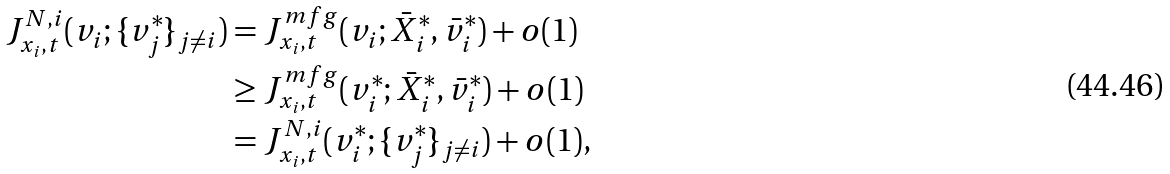<formula> <loc_0><loc_0><loc_500><loc_500>J _ { x _ { i } , t } ^ { N , i } ( v _ { i } ; \{ v ^ { * } _ { j } \} _ { j \neq i } ) & = J _ { x _ { i } , t } ^ { m f g } ( v _ { i } ; \bar { X } _ { i } ^ { * } , \bar { v } ^ { * } _ { i } ) + o ( 1 ) \\ & \geq J _ { x _ { i } , t } ^ { m f g } ( v ^ { * } _ { i } ; \bar { X } _ { i } ^ { * } , \bar { v } ^ { * } _ { i } ) + o ( 1 ) \\ & = J _ { x _ { i } , t } ^ { N , i } ( v ^ { * } _ { i } ; \{ v ^ { * } _ { j } \} _ { j \neq i } ) + o ( 1 ) ,</formula> 